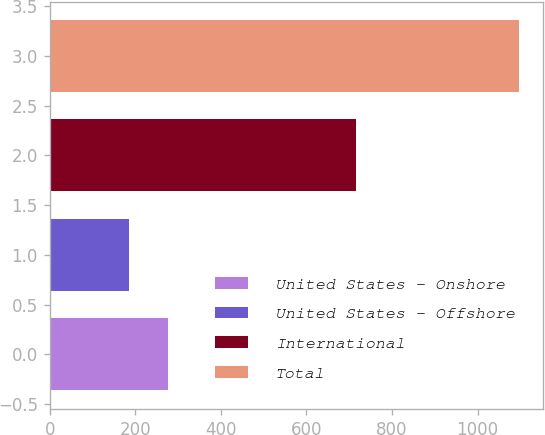Convert chart. <chart><loc_0><loc_0><loc_500><loc_500><bar_chart><fcel>United States - Onshore<fcel>United States - Offshore<fcel>International<fcel>Total<nl><fcel>277.2<fcel>186<fcel>716<fcel>1098<nl></chart> 